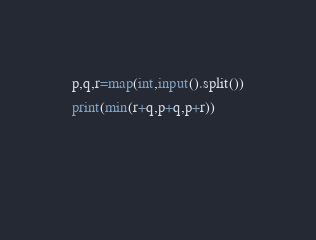<code> <loc_0><loc_0><loc_500><loc_500><_Python_>p,q,r=map(int,input().split())
print(min(r+q,p+q,p+r))

  </code> 